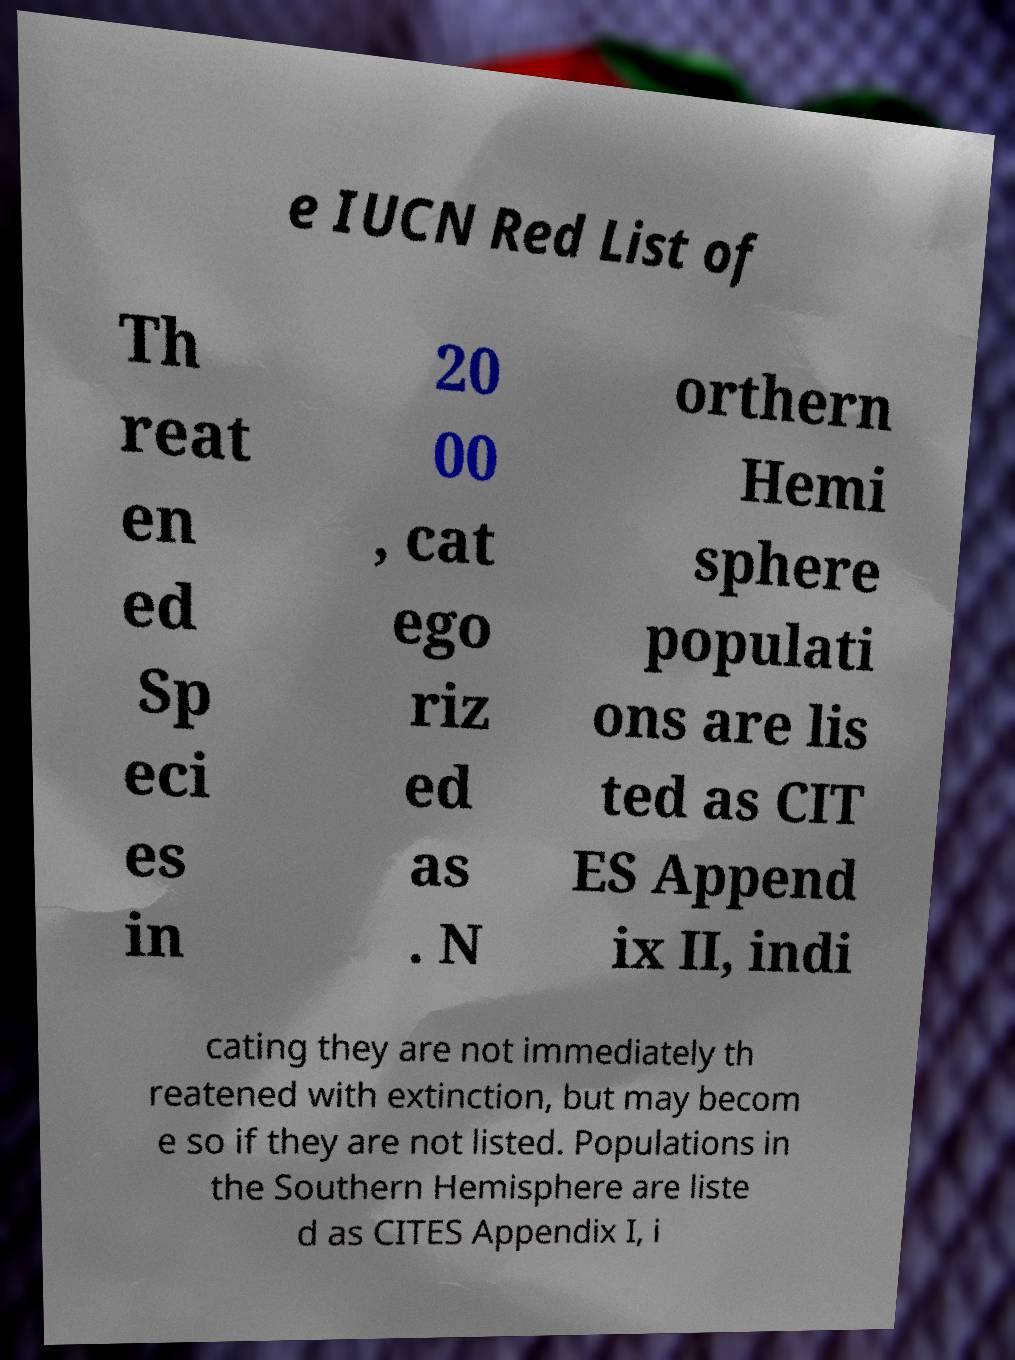Can you read and provide the text displayed in the image?This photo seems to have some interesting text. Can you extract and type it out for me? e IUCN Red List of Th reat en ed Sp eci es in 20 00 , cat ego riz ed as . N orthern Hemi sphere populati ons are lis ted as CIT ES Append ix II, indi cating they are not immediately th reatened with extinction, but may becom e so if they are not listed. Populations in the Southern Hemisphere are liste d as CITES Appendix I, i 